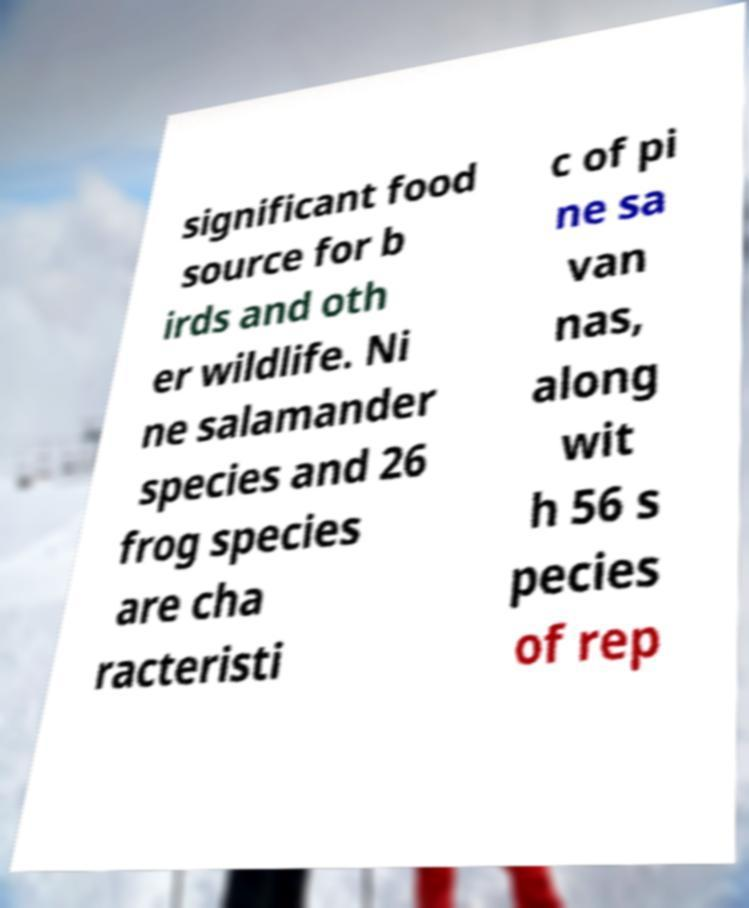Please identify and transcribe the text found in this image. significant food source for b irds and oth er wildlife. Ni ne salamander species and 26 frog species are cha racteristi c of pi ne sa van nas, along wit h 56 s pecies of rep 